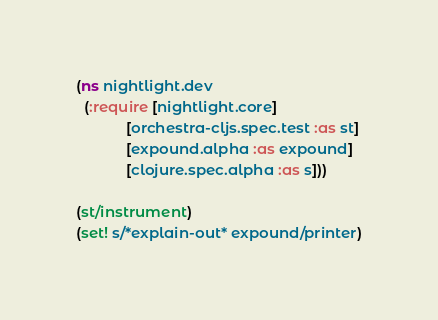<code> <loc_0><loc_0><loc_500><loc_500><_Clojure_>(ns nightlight.dev
  (:require [nightlight.core]
            [orchestra-cljs.spec.test :as st]
            [expound.alpha :as expound]
            [clojure.spec.alpha :as s]))

(st/instrument)
(set! s/*explain-out* expound/printer)
</code> 